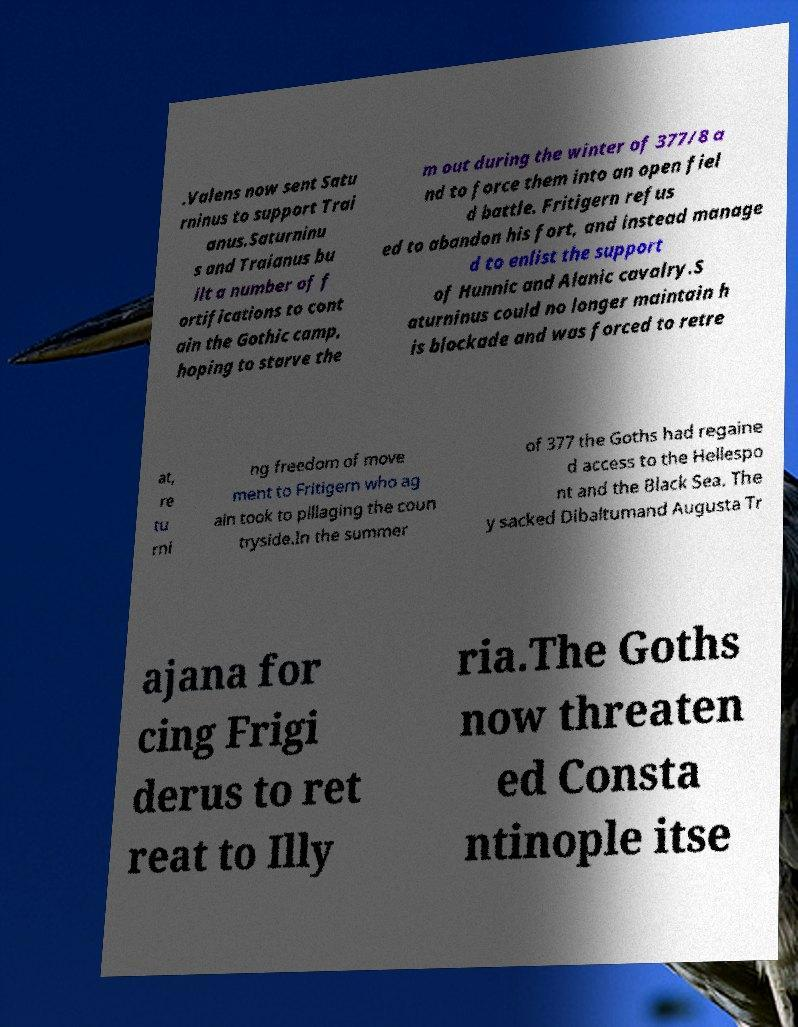Can you read and provide the text displayed in the image?This photo seems to have some interesting text. Can you extract and type it out for me? .Valens now sent Satu rninus to support Trai anus.Saturninu s and Traianus bu ilt a number of f ortifications to cont ain the Gothic camp, hoping to starve the m out during the winter of 377/8 a nd to force them into an open fiel d battle. Fritigern refus ed to abandon his fort, and instead manage d to enlist the support of Hunnic and Alanic cavalry.S aturninus could no longer maintain h is blockade and was forced to retre at, re tu rni ng freedom of move ment to Fritigern who ag ain took to pillaging the coun tryside.In the summer of 377 the Goths had regaine d access to the Hellespo nt and the Black Sea. The y sacked Dibaltumand Augusta Tr ajana for cing Frigi derus to ret reat to Illy ria.The Goths now threaten ed Consta ntinople itse 